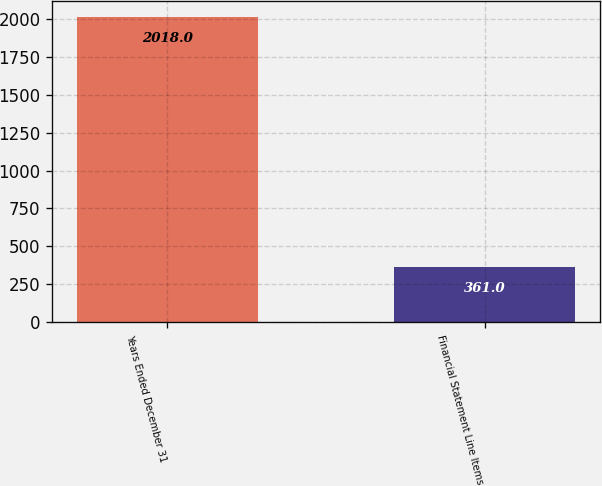<chart> <loc_0><loc_0><loc_500><loc_500><bar_chart><fcel>Years Ended December 31<fcel>Financial Statement Line Items<nl><fcel>2018<fcel>361<nl></chart> 